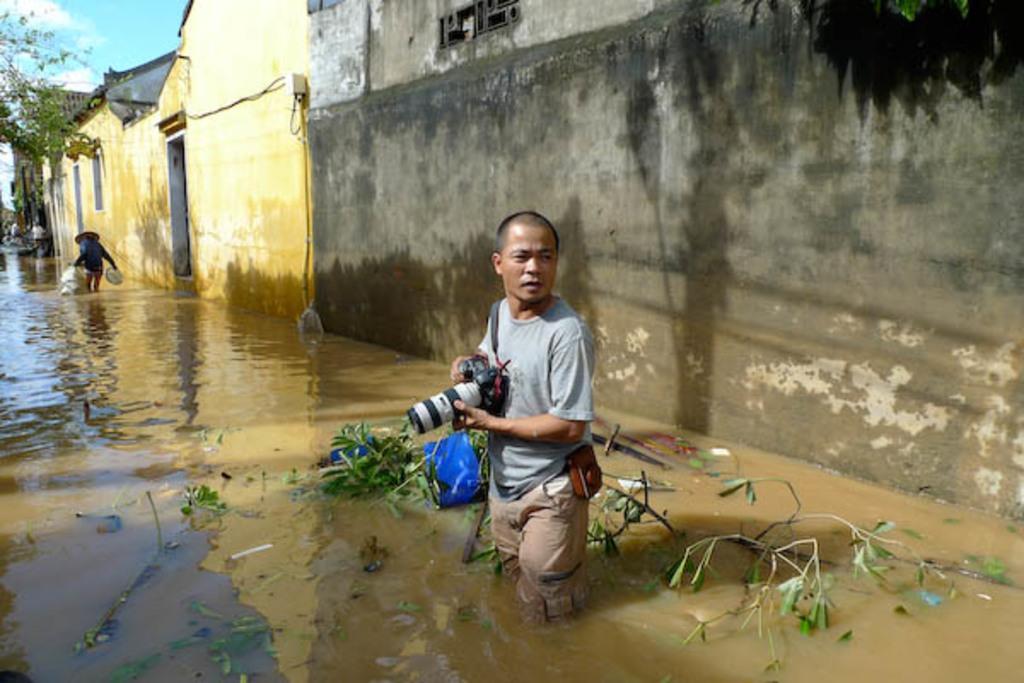In one or two sentences, can you explain what this image depicts? In this image there are some houses and at the bottom there are two persons one person is holding a camera, and one person is holding some bags and walking. And at the bottom the area is filled with some water, and in the background there are some trees and some persons. At the top of the image there is sky. 